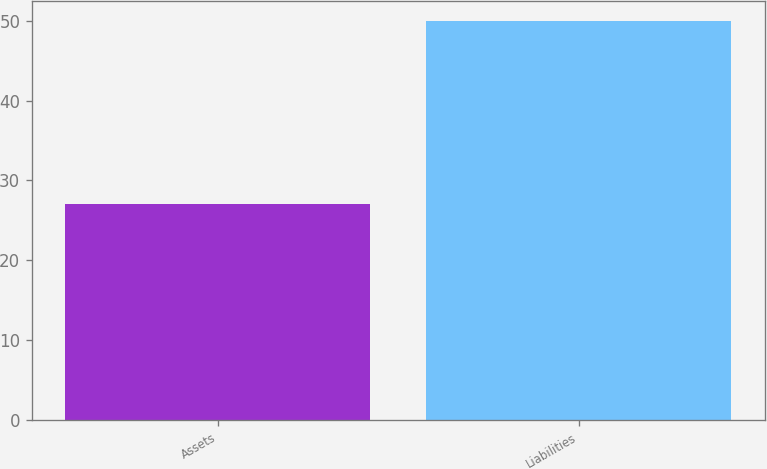Convert chart. <chart><loc_0><loc_0><loc_500><loc_500><bar_chart><fcel>Assets<fcel>Liabilities<nl><fcel>27<fcel>50<nl></chart> 